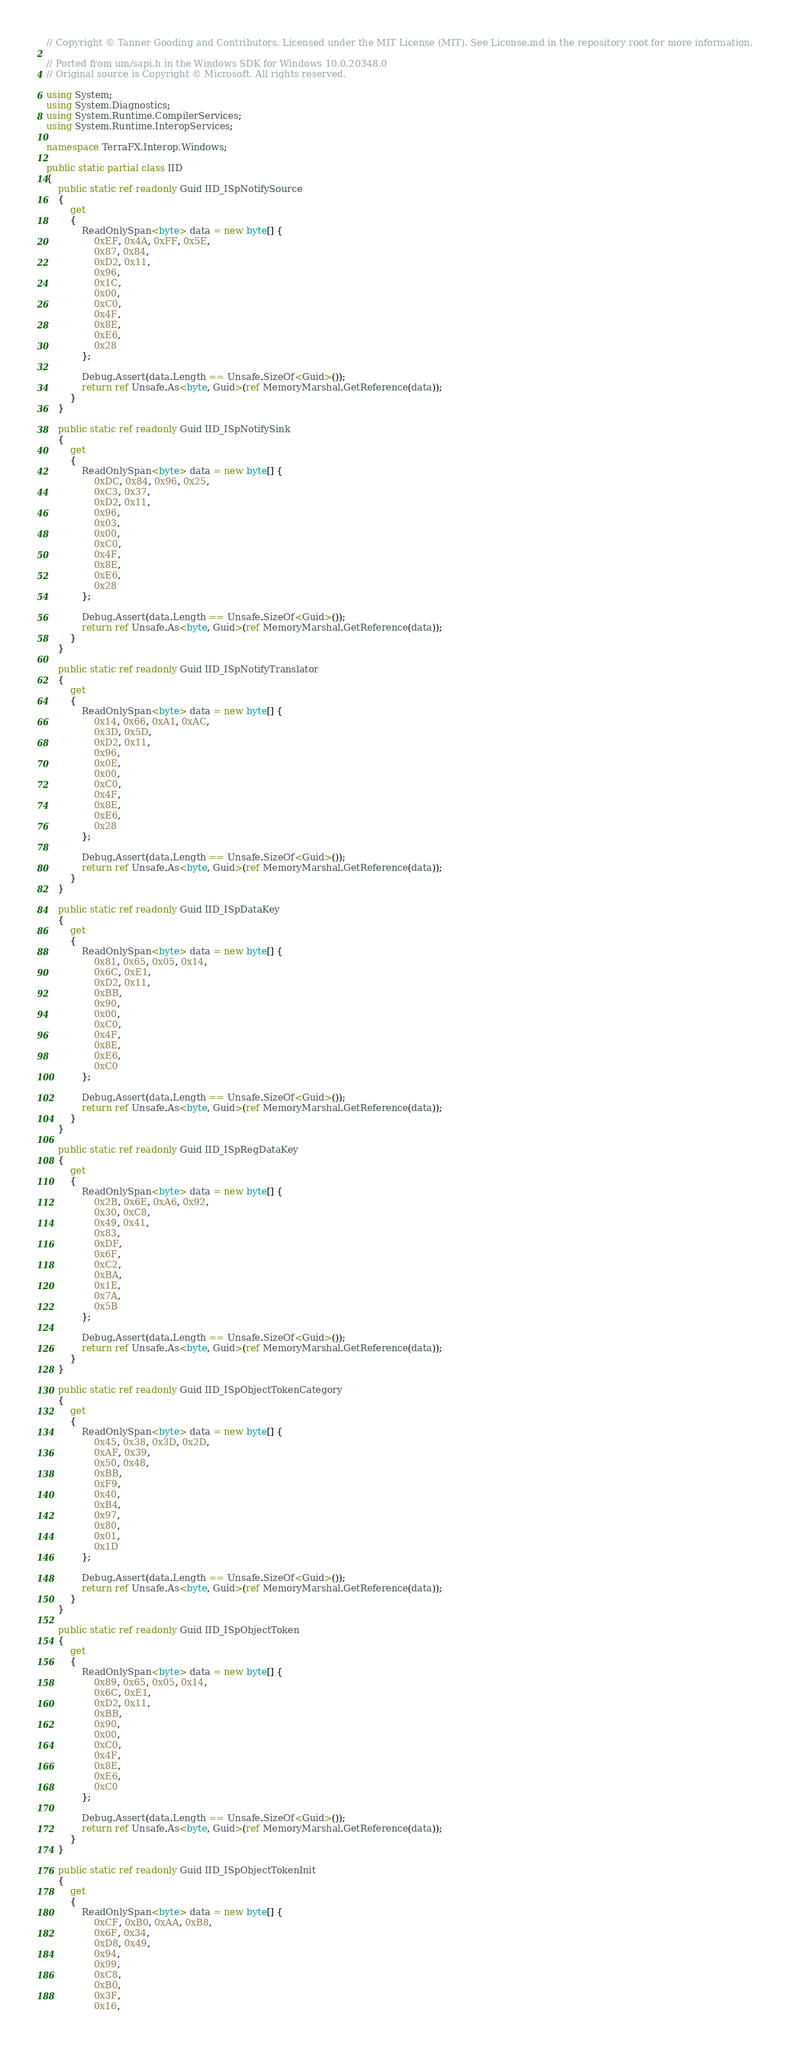<code> <loc_0><loc_0><loc_500><loc_500><_C#_>// Copyright © Tanner Gooding and Contributors. Licensed under the MIT License (MIT). See License.md in the repository root for more information.

// Ported from um/sapi.h in the Windows SDK for Windows 10.0.20348.0
// Original source is Copyright © Microsoft. All rights reserved.

using System;
using System.Diagnostics;
using System.Runtime.CompilerServices;
using System.Runtime.InteropServices;

namespace TerraFX.Interop.Windows;

public static partial class IID
{
    public static ref readonly Guid IID_ISpNotifySource
    {
        get
        {
            ReadOnlySpan<byte> data = new byte[] {
                0xEF, 0x4A, 0xFF, 0x5E,
                0x87, 0x84,
                0xD2, 0x11,
                0x96,
                0x1C,
                0x00,
                0xC0,
                0x4F,
                0x8E,
                0xE6,
                0x28
            };

            Debug.Assert(data.Length == Unsafe.SizeOf<Guid>());
            return ref Unsafe.As<byte, Guid>(ref MemoryMarshal.GetReference(data));
        }
    }

    public static ref readonly Guid IID_ISpNotifySink
    {
        get
        {
            ReadOnlySpan<byte> data = new byte[] {
                0xDC, 0x84, 0x96, 0x25,
                0xC3, 0x37,
                0xD2, 0x11,
                0x96,
                0x03,
                0x00,
                0xC0,
                0x4F,
                0x8E,
                0xE6,
                0x28
            };

            Debug.Assert(data.Length == Unsafe.SizeOf<Guid>());
            return ref Unsafe.As<byte, Guid>(ref MemoryMarshal.GetReference(data));
        }
    }

    public static ref readonly Guid IID_ISpNotifyTranslator
    {
        get
        {
            ReadOnlySpan<byte> data = new byte[] {
                0x14, 0x66, 0xA1, 0xAC,
                0x3D, 0x5D,
                0xD2, 0x11,
                0x96,
                0x0E,
                0x00,
                0xC0,
                0x4F,
                0x8E,
                0xE6,
                0x28
            };

            Debug.Assert(data.Length == Unsafe.SizeOf<Guid>());
            return ref Unsafe.As<byte, Guid>(ref MemoryMarshal.GetReference(data));
        }
    }

    public static ref readonly Guid IID_ISpDataKey
    {
        get
        {
            ReadOnlySpan<byte> data = new byte[] {
                0x81, 0x65, 0x05, 0x14,
                0x6C, 0xE1,
                0xD2, 0x11,
                0xBB,
                0x90,
                0x00,
                0xC0,
                0x4F,
                0x8E,
                0xE6,
                0xC0
            };

            Debug.Assert(data.Length == Unsafe.SizeOf<Guid>());
            return ref Unsafe.As<byte, Guid>(ref MemoryMarshal.GetReference(data));
        }
    }

    public static ref readonly Guid IID_ISpRegDataKey
    {
        get
        {
            ReadOnlySpan<byte> data = new byte[] {
                0x2B, 0x6E, 0xA6, 0x92,
                0x30, 0xC8,
                0x49, 0x41,
                0x83,
                0xDF,
                0x6F,
                0xC2,
                0xBA,
                0x1E,
                0x7A,
                0x5B
            };

            Debug.Assert(data.Length == Unsafe.SizeOf<Guid>());
            return ref Unsafe.As<byte, Guid>(ref MemoryMarshal.GetReference(data));
        }
    }

    public static ref readonly Guid IID_ISpObjectTokenCategory
    {
        get
        {
            ReadOnlySpan<byte> data = new byte[] {
                0x45, 0x38, 0x3D, 0x2D,
                0xAF, 0x39,
                0x50, 0x48,
                0xBB,
                0xF9,
                0x40,
                0xB4,
                0x97,
                0x80,
                0x01,
                0x1D
            };

            Debug.Assert(data.Length == Unsafe.SizeOf<Guid>());
            return ref Unsafe.As<byte, Guid>(ref MemoryMarshal.GetReference(data));
        }
    }

    public static ref readonly Guid IID_ISpObjectToken
    {
        get
        {
            ReadOnlySpan<byte> data = new byte[] {
                0x89, 0x65, 0x05, 0x14,
                0x6C, 0xE1,
                0xD2, 0x11,
                0xBB,
                0x90,
                0x00,
                0xC0,
                0x4F,
                0x8E,
                0xE6,
                0xC0
            };

            Debug.Assert(data.Length == Unsafe.SizeOf<Guid>());
            return ref Unsafe.As<byte, Guid>(ref MemoryMarshal.GetReference(data));
        }
    }

    public static ref readonly Guid IID_ISpObjectTokenInit
    {
        get
        {
            ReadOnlySpan<byte> data = new byte[] {
                0xCF, 0xB0, 0xAA, 0xB8,
                0x6F, 0x34,
                0xD8, 0x49,
                0x94,
                0x99,
                0xC8,
                0xB0,
                0x3F,
                0x16,</code> 